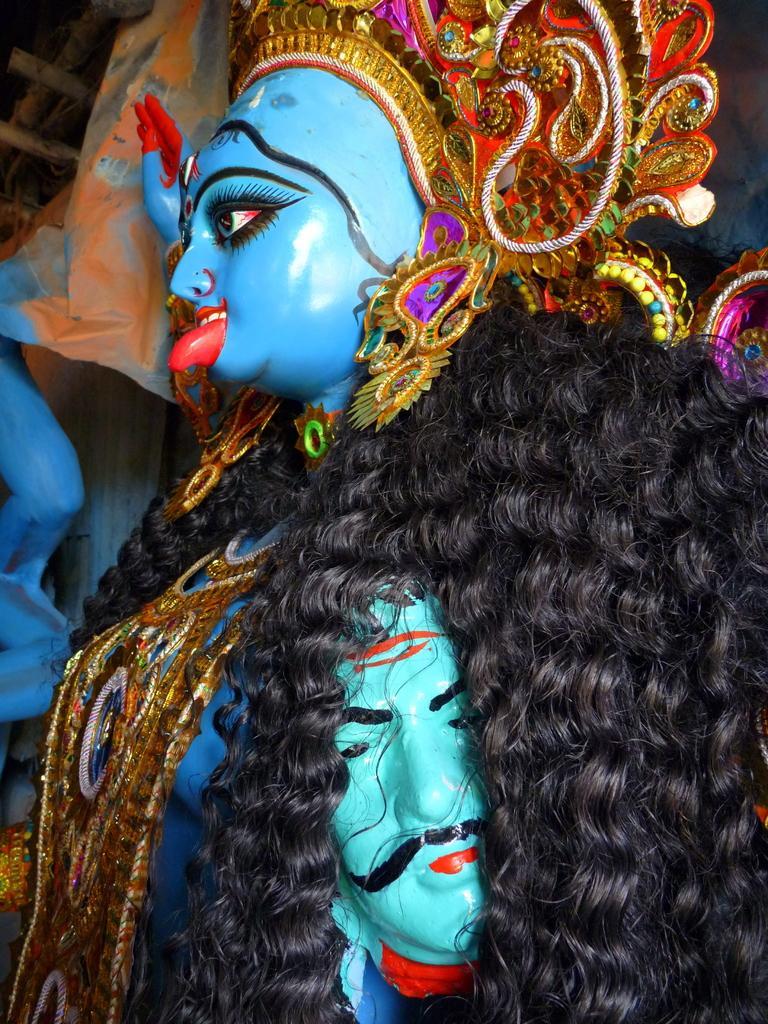Could you give a brief overview of what you see in this image? In this picture I can see the sculpture of a woman and a man in front and I see that these sculptures are colorful. 